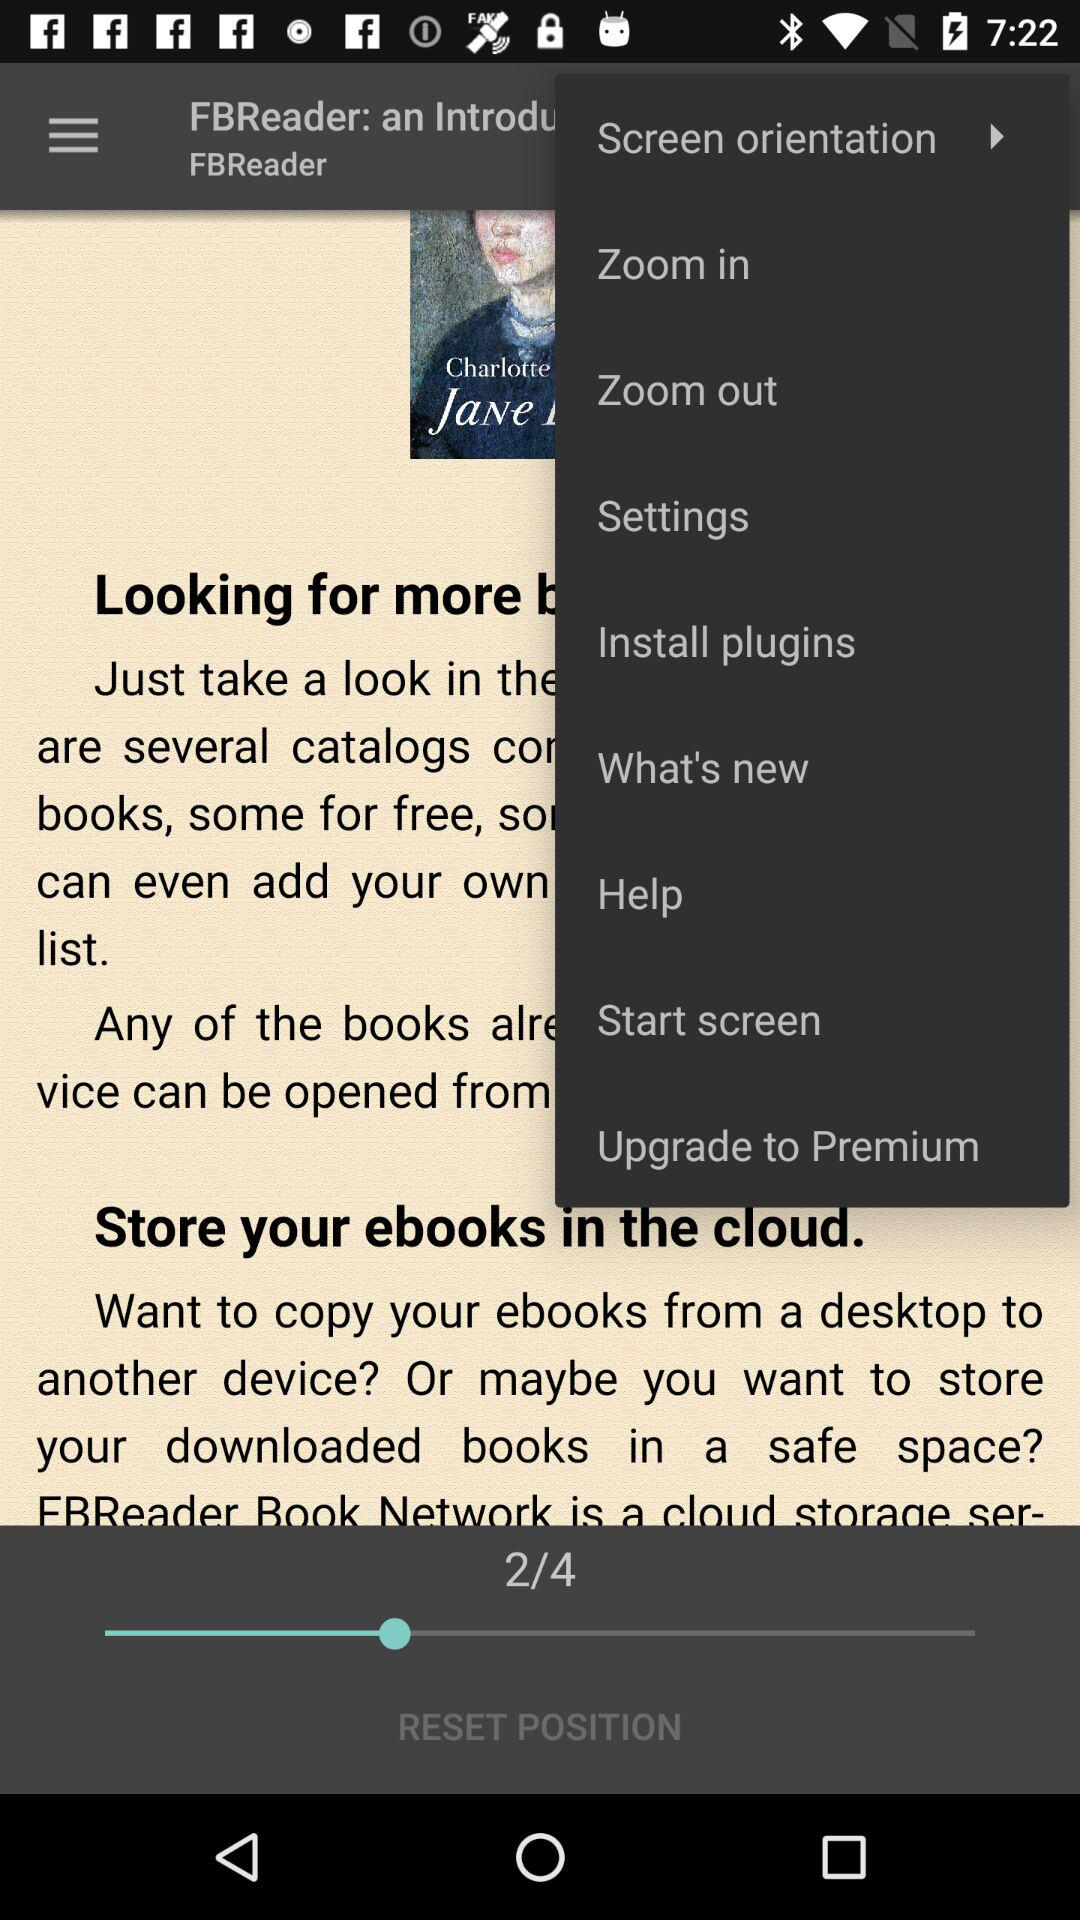How many reset positions are there? There are 4 reset positions. 